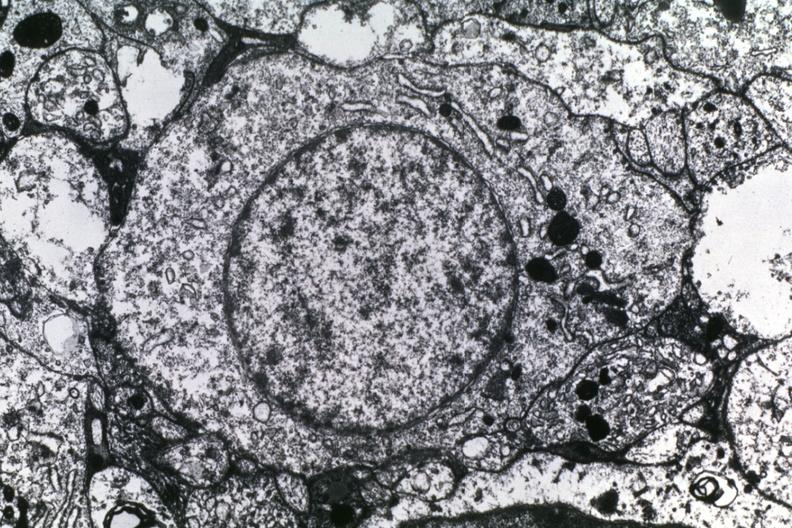s this great toe present?
Answer the question using a single word or phrase. No 